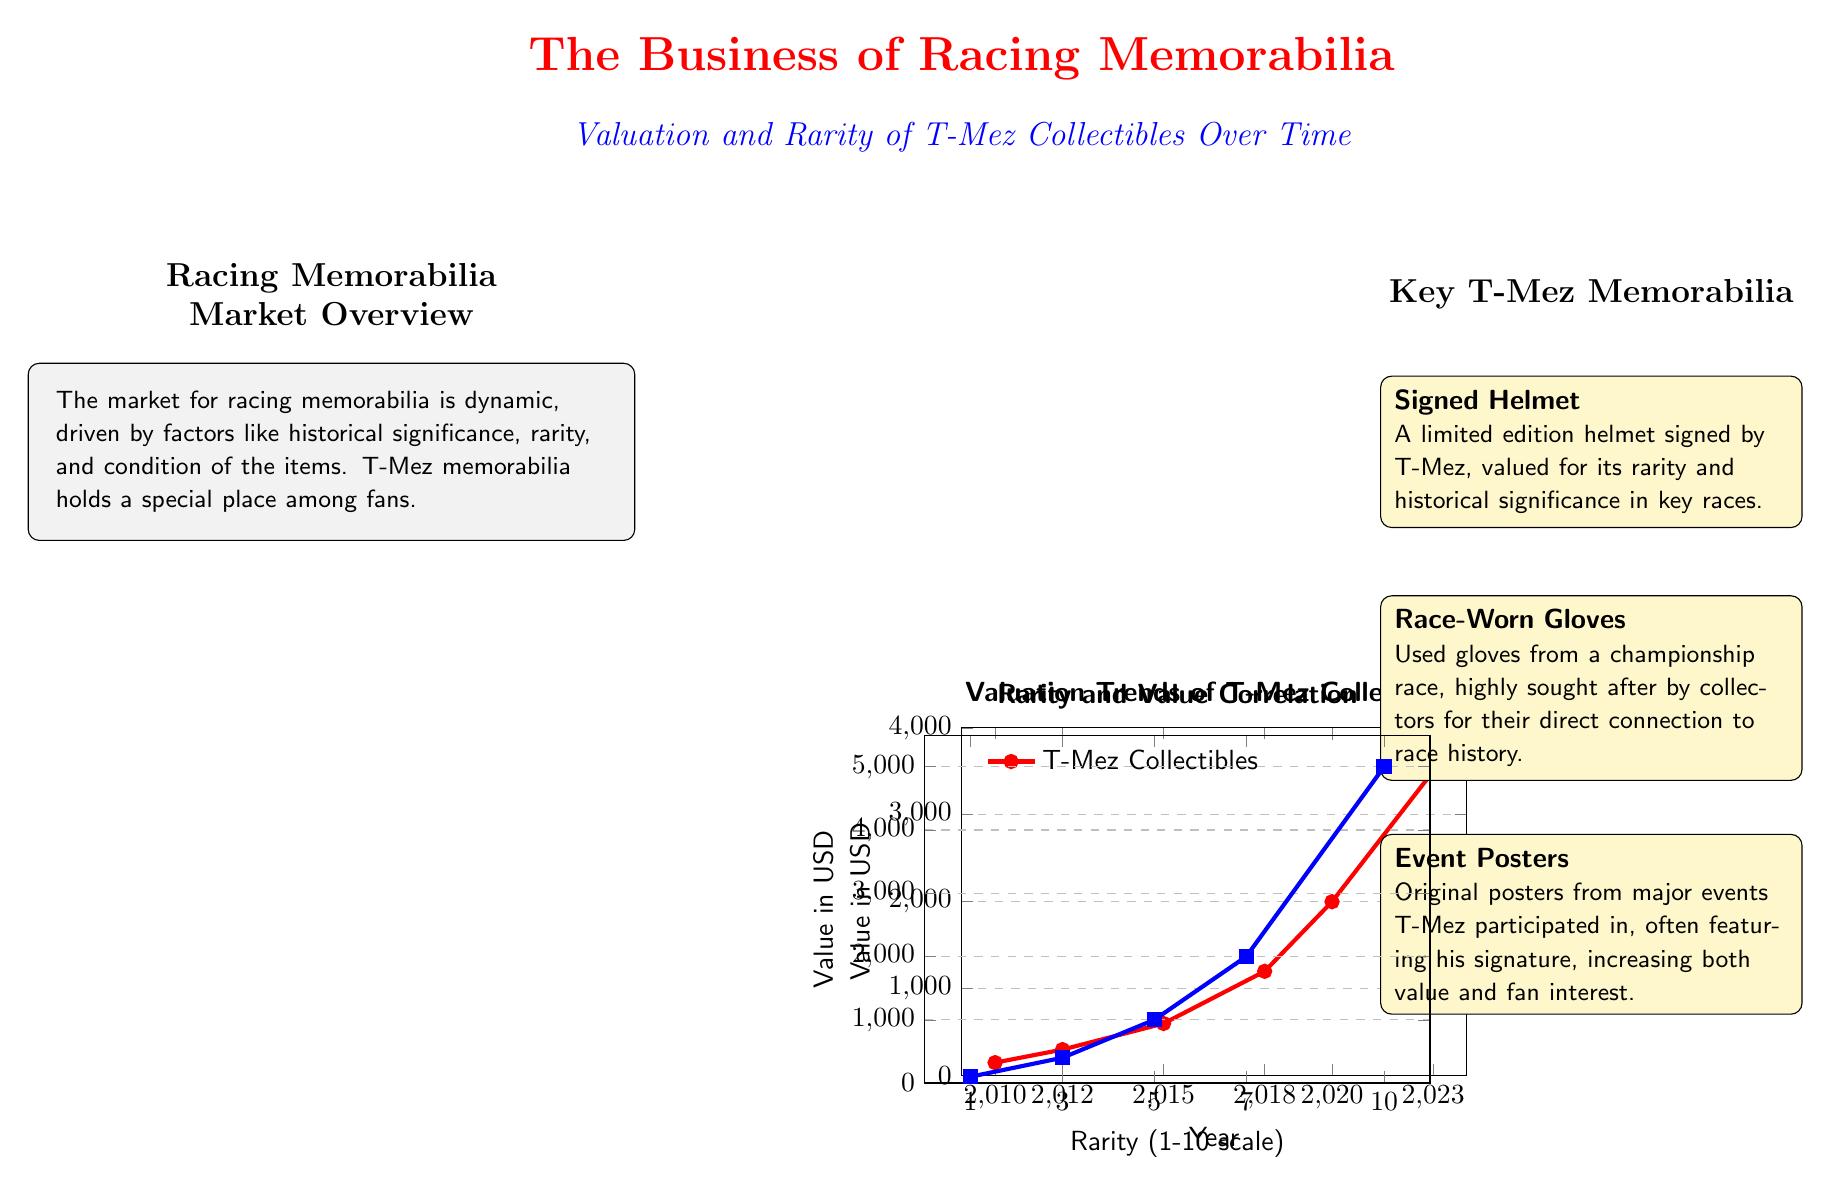What is the highest recorded value of T-Mez collectibles in 2023? Looking at the Valuation Trends Chart, we see that the highest value reaches 3500 USD in the year 2023.
Answer: 3500 USD What year did the value of T-Mez collectibles first exceed 1000 USD? By reviewing the Valuation Trends Chart, the value first exceeds 1000 USD in the year 2018.
Answer: 2018 What is the approximate value of T-Mez collectibles in 2015? Referring to the Valuation Trends Chart, the value in 2015 is noted to be 600 USD.
Answer: 600 USD How many key items of T-Mez memorabilia are listed in the diagram? The diagram lists three key items of T-Mez memorabilia: Signed Helmet, Race-Worn Gloves, and Event Posters. Therefore, the total is three items.
Answer: three What is the correlation between rarity and value at a rarity level of 10? According to the Rarity and Value Correlation Chart, at a rarity level of 10, the value is 5000 USD.
Answer: 5000 USD In which year did the value of T-Mez collectibles increase by the largest amount compared to the previous year? The greatest increase occurs between 2020 and 2023, where the value rises from 2000 USD to 3500 USD, an increase of 1500 USD.
Answer: 1500 USD What is the value of an item rated with a rarity of 5? From the Rarity and Value Correlation Chart, an item with a rarity rating of 5 has a value of 1000 USD.
Answer: 1000 USD What color represents the value of T-Mez collectibles on the Valuation Trends Chart? The color associated with the value of T-Mez collectibles in the Valuation Trends Chart is racing red.
Answer: racing red 